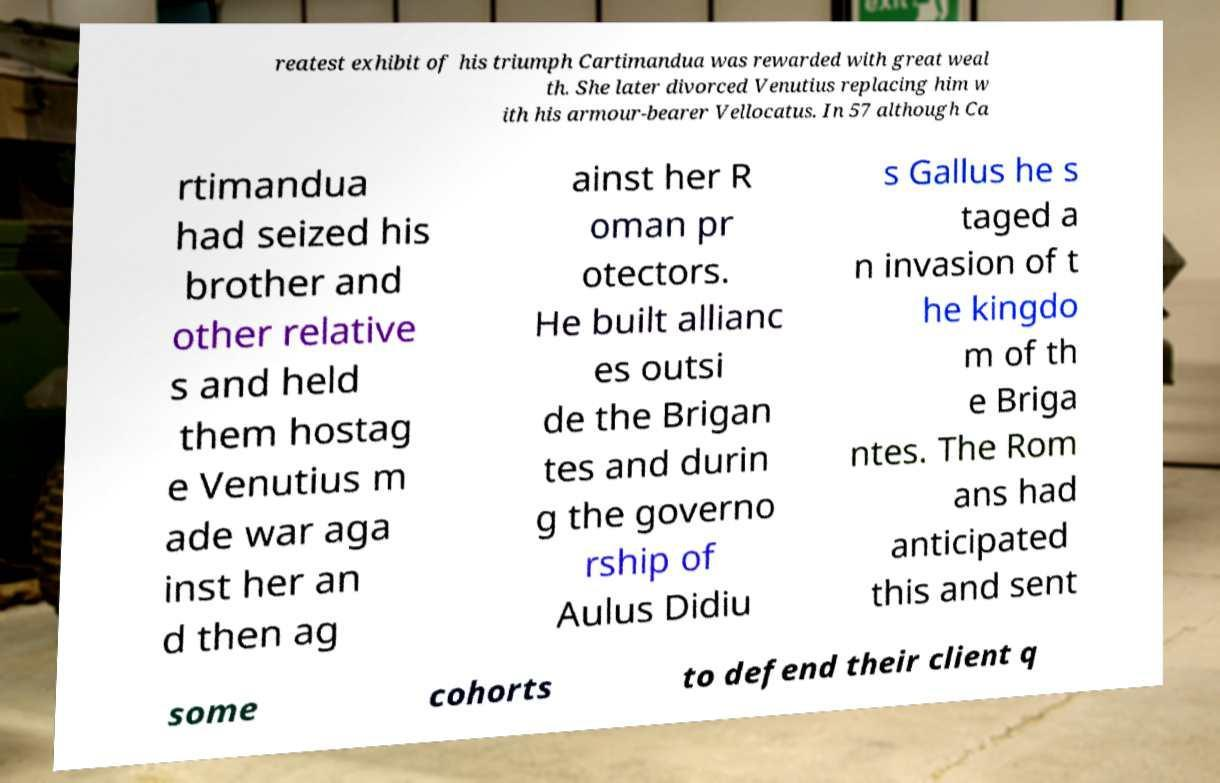Can you accurately transcribe the text from the provided image for me? reatest exhibit of his triumph Cartimandua was rewarded with great weal th. She later divorced Venutius replacing him w ith his armour-bearer Vellocatus. In 57 although Ca rtimandua had seized his brother and other relative s and held them hostag e Venutius m ade war aga inst her an d then ag ainst her R oman pr otectors. He built allianc es outsi de the Brigan tes and durin g the governo rship of Aulus Didiu s Gallus he s taged a n invasion of t he kingdo m of th e Briga ntes. The Rom ans had anticipated this and sent some cohorts to defend their client q 